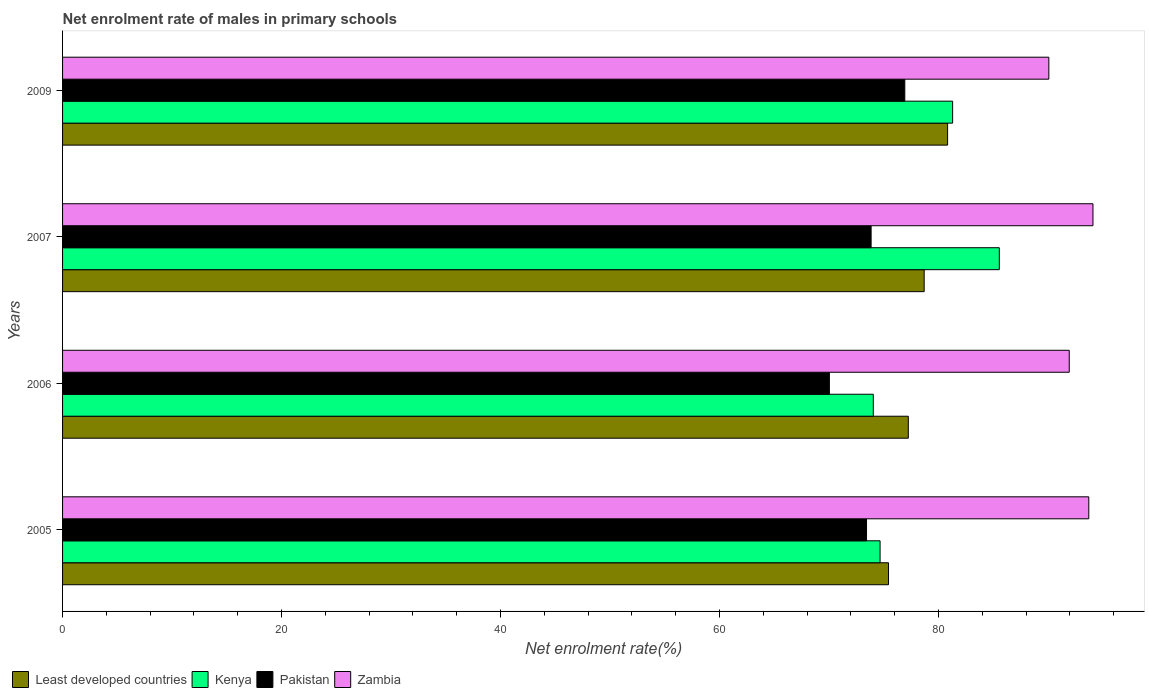How many different coloured bars are there?
Your answer should be very brief. 4. Are the number of bars on each tick of the Y-axis equal?
Your answer should be very brief. Yes. How many bars are there on the 4th tick from the top?
Keep it short and to the point. 4. What is the label of the 3rd group of bars from the top?
Your response must be concise. 2006. What is the net enrolment rate of males in primary schools in Zambia in 2006?
Provide a short and direct response. 91.95. Across all years, what is the maximum net enrolment rate of males in primary schools in Least developed countries?
Keep it short and to the point. 80.84. Across all years, what is the minimum net enrolment rate of males in primary schools in Least developed countries?
Provide a short and direct response. 75.44. In which year was the net enrolment rate of males in primary schools in Pakistan minimum?
Keep it short and to the point. 2006. What is the total net enrolment rate of males in primary schools in Pakistan in the graph?
Your answer should be very brief. 294.25. What is the difference between the net enrolment rate of males in primary schools in Pakistan in 2005 and that in 2007?
Provide a succinct answer. -0.42. What is the difference between the net enrolment rate of males in primary schools in Least developed countries in 2006 and the net enrolment rate of males in primary schools in Pakistan in 2005?
Offer a very short reply. 3.82. What is the average net enrolment rate of males in primary schools in Zambia per year?
Offer a terse response. 92.47. In the year 2009, what is the difference between the net enrolment rate of males in primary schools in Kenya and net enrolment rate of males in primary schools in Least developed countries?
Ensure brevity in your answer.  0.46. In how many years, is the net enrolment rate of males in primary schools in Pakistan greater than 16 %?
Your answer should be compact. 4. What is the ratio of the net enrolment rate of males in primary schools in Least developed countries in 2007 to that in 2009?
Offer a very short reply. 0.97. Is the net enrolment rate of males in primary schools in Pakistan in 2005 less than that in 2006?
Your answer should be compact. No. What is the difference between the highest and the second highest net enrolment rate of males in primary schools in Pakistan?
Offer a very short reply. 3.08. What is the difference between the highest and the lowest net enrolment rate of males in primary schools in Zambia?
Make the answer very short. 4.03. What does the 3rd bar from the top in 2007 represents?
Provide a succinct answer. Kenya. What does the 4th bar from the bottom in 2007 represents?
Offer a very short reply. Zambia. How many bars are there?
Ensure brevity in your answer.  16. How many years are there in the graph?
Offer a terse response. 4. What is the difference between two consecutive major ticks on the X-axis?
Offer a terse response. 20. Does the graph contain grids?
Offer a terse response. No. Where does the legend appear in the graph?
Ensure brevity in your answer.  Bottom left. How are the legend labels stacked?
Your answer should be very brief. Horizontal. What is the title of the graph?
Give a very brief answer. Net enrolment rate of males in primary schools. Does "Guatemala" appear as one of the legend labels in the graph?
Provide a succinct answer. No. What is the label or title of the X-axis?
Ensure brevity in your answer.  Net enrolment rate(%). What is the label or title of the Y-axis?
Give a very brief answer. Years. What is the Net enrolment rate(%) in Least developed countries in 2005?
Offer a very short reply. 75.44. What is the Net enrolment rate(%) of Kenya in 2005?
Your answer should be very brief. 74.67. What is the Net enrolment rate(%) of Pakistan in 2005?
Provide a short and direct response. 73.43. What is the Net enrolment rate(%) of Zambia in 2005?
Offer a terse response. 93.74. What is the Net enrolment rate(%) of Least developed countries in 2006?
Provide a short and direct response. 77.25. What is the Net enrolment rate(%) in Kenya in 2006?
Offer a terse response. 74.05. What is the Net enrolment rate(%) of Pakistan in 2006?
Your answer should be very brief. 70.04. What is the Net enrolment rate(%) of Zambia in 2006?
Keep it short and to the point. 91.95. What is the Net enrolment rate(%) of Least developed countries in 2007?
Give a very brief answer. 78.7. What is the Net enrolment rate(%) in Kenya in 2007?
Offer a very short reply. 85.56. What is the Net enrolment rate(%) of Pakistan in 2007?
Your answer should be very brief. 73.85. What is the Net enrolment rate(%) in Zambia in 2007?
Keep it short and to the point. 94.12. What is the Net enrolment rate(%) in Least developed countries in 2009?
Give a very brief answer. 80.84. What is the Net enrolment rate(%) of Kenya in 2009?
Provide a succinct answer. 81.3. What is the Net enrolment rate(%) of Pakistan in 2009?
Keep it short and to the point. 76.93. What is the Net enrolment rate(%) of Zambia in 2009?
Keep it short and to the point. 90.09. Across all years, what is the maximum Net enrolment rate(%) of Least developed countries?
Provide a succinct answer. 80.84. Across all years, what is the maximum Net enrolment rate(%) in Kenya?
Make the answer very short. 85.56. Across all years, what is the maximum Net enrolment rate(%) of Pakistan?
Provide a short and direct response. 76.93. Across all years, what is the maximum Net enrolment rate(%) of Zambia?
Offer a terse response. 94.12. Across all years, what is the minimum Net enrolment rate(%) in Least developed countries?
Ensure brevity in your answer.  75.44. Across all years, what is the minimum Net enrolment rate(%) in Kenya?
Ensure brevity in your answer.  74.05. Across all years, what is the minimum Net enrolment rate(%) in Pakistan?
Provide a short and direct response. 70.04. Across all years, what is the minimum Net enrolment rate(%) in Zambia?
Keep it short and to the point. 90.09. What is the total Net enrolment rate(%) of Least developed countries in the graph?
Provide a succinct answer. 312.23. What is the total Net enrolment rate(%) of Kenya in the graph?
Ensure brevity in your answer.  315.58. What is the total Net enrolment rate(%) of Pakistan in the graph?
Your answer should be very brief. 294.25. What is the total Net enrolment rate(%) of Zambia in the graph?
Keep it short and to the point. 369.88. What is the difference between the Net enrolment rate(%) in Least developed countries in 2005 and that in 2006?
Your answer should be very brief. -1.81. What is the difference between the Net enrolment rate(%) of Kenya in 2005 and that in 2006?
Your answer should be very brief. 0.62. What is the difference between the Net enrolment rate(%) in Pakistan in 2005 and that in 2006?
Provide a short and direct response. 3.39. What is the difference between the Net enrolment rate(%) of Zambia in 2005 and that in 2006?
Your response must be concise. 1.79. What is the difference between the Net enrolment rate(%) in Least developed countries in 2005 and that in 2007?
Your answer should be very brief. -3.26. What is the difference between the Net enrolment rate(%) of Kenya in 2005 and that in 2007?
Provide a short and direct response. -10.89. What is the difference between the Net enrolment rate(%) of Pakistan in 2005 and that in 2007?
Your answer should be compact. -0.42. What is the difference between the Net enrolment rate(%) in Zambia in 2005 and that in 2007?
Your answer should be very brief. -0.38. What is the difference between the Net enrolment rate(%) in Least developed countries in 2005 and that in 2009?
Provide a succinct answer. -5.4. What is the difference between the Net enrolment rate(%) of Kenya in 2005 and that in 2009?
Make the answer very short. -6.63. What is the difference between the Net enrolment rate(%) in Pakistan in 2005 and that in 2009?
Your answer should be compact. -3.49. What is the difference between the Net enrolment rate(%) of Zambia in 2005 and that in 2009?
Your response must be concise. 3.65. What is the difference between the Net enrolment rate(%) of Least developed countries in 2006 and that in 2007?
Offer a terse response. -1.45. What is the difference between the Net enrolment rate(%) in Kenya in 2006 and that in 2007?
Your answer should be compact. -11.51. What is the difference between the Net enrolment rate(%) in Pakistan in 2006 and that in 2007?
Keep it short and to the point. -3.81. What is the difference between the Net enrolment rate(%) in Zambia in 2006 and that in 2007?
Your response must be concise. -2.17. What is the difference between the Net enrolment rate(%) in Least developed countries in 2006 and that in 2009?
Provide a short and direct response. -3.59. What is the difference between the Net enrolment rate(%) of Kenya in 2006 and that in 2009?
Provide a succinct answer. -7.25. What is the difference between the Net enrolment rate(%) of Pakistan in 2006 and that in 2009?
Offer a very short reply. -6.89. What is the difference between the Net enrolment rate(%) in Zambia in 2006 and that in 2009?
Offer a terse response. 1.86. What is the difference between the Net enrolment rate(%) of Least developed countries in 2007 and that in 2009?
Offer a terse response. -2.14. What is the difference between the Net enrolment rate(%) of Kenya in 2007 and that in 2009?
Offer a terse response. 4.26. What is the difference between the Net enrolment rate(%) of Pakistan in 2007 and that in 2009?
Your response must be concise. -3.08. What is the difference between the Net enrolment rate(%) in Zambia in 2007 and that in 2009?
Offer a terse response. 4.03. What is the difference between the Net enrolment rate(%) in Least developed countries in 2005 and the Net enrolment rate(%) in Kenya in 2006?
Offer a terse response. 1.39. What is the difference between the Net enrolment rate(%) of Least developed countries in 2005 and the Net enrolment rate(%) of Pakistan in 2006?
Keep it short and to the point. 5.4. What is the difference between the Net enrolment rate(%) in Least developed countries in 2005 and the Net enrolment rate(%) in Zambia in 2006?
Offer a terse response. -16.51. What is the difference between the Net enrolment rate(%) in Kenya in 2005 and the Net enrolment rate(%) in Pakistan in 2006?
Provide a short and direct response. 4.63. What is the difference between the Net enrolment rate(%) of Kenya in 2005 and the Net enrolment rate(%) of Zambia in 2006?
Your response must be concise. -17.28. What is the difference between the Net enrolment rate(%) of Pakistan in 2005 and the Net enrolment rate(%) of Zambia in 2006?
Your answer should be compact. -18.52. What is the difference between the Net enrolment rate(%) in Least developed countries in 2005 and the Net enrolment rate(%) in Kenya in 2007?
Your answer should be compact. -10.12. What is the difference between the Net enrolment rate(%) of Least developed countries in 2005 and the Net enrolment rate(%) of Pakistan in 2007?
Offer a very short reply. 1.59. What is the difference between the Net enrolment rate(%) of Least developed countries in 2005 and the Net enrolment rate(%) of Zambia in 2007?
Provide a succinct answer. -18.67. What is the difference between the Net enrolment rate(%) of Kenya in 2005 and the Net enrolment rate(%) of Pakistan in 2007?
Keep it short and to the point. 0.82. What is the difference between the Net enrolment rate(%) in Kenya in 2005 and the Net enrolment rate(%) in Zambia in 2007?
Keep it short and to the point. -19.45. What is the difference between the Net enrolment rate(%) in Pakistan in 2005 and the Net enrolment rate(%) in Zambia in 2007?
Offer a terse response. -20.68. What is the difference between the Net enrolment rate(%) of Least developed countries in 2005 and the Net enrolment rate(%) of Kenya in 2009?
Your response must be concise. -5.86. What is the difference between the Net enrolment rate(%) in Least developed countries in 2005 and the Net enrolment rate(%) in Pakistan in 2009?
Provide a short and direct response. -1.49. What is the difference between the Net enrolment rate(%) in Least developed countries in 2005 and the Net enrolment rate(%) in Zambia in 2009?
Make the answer very short. -14.64. What is the difference between the Net enrolment rate(%) in Kenya in 2005 and the Net enrolment rate(%) in Pakistan in 2009?
Your response must be concise. -2.26. What is the difference between the Net enrolment rate(%) in Kenya in 2005 and the Net enrolment rate(%) in Zambia in 2009?
Keep it short and to the point. -15.41. What is the difference between the Net enrolment rate(%) of Pakistan in 2005 and the Net enrolment rate(%) of Zambia in 2009?
Your answer should be very brief. -16.65. What is the difference between the Net enrolment rate(%) in Least developed countries in 2006 and the Net enrolment rate(%) in Kenya in 2007?
Keep it short and to the point. -8.31. What is the difference between the Net enrolment rate(%) of Least developed countries in 2006 and the Net enrolment rate(%) of Pakistan in 2007?
Your answer should be compact. 3.4. What is the difference between the Net enrolment rate(%) of Least developed countries in 2006 and the Net enrolment rate(%) of Zambia in 2007?
Your answer should be compact. -16.87. What is the difference between the Net enrolment rate(%) of Kenya in 2006 and the Net enrolment rate(%) of Pakistan in 2007?
Provide a succinct answer. 0.2. What is the difference between the Net enrolment rate(%) of Kenya in 2006 and the Net enrolment rate(%) of Zambia in 2007?
Make the answer very short. -20.07. What is the difference between the Net enrolment rate(%) in Pakistan in 2006 and the Net enrolment rate(%) in Zambia in 2007?
Offer a very short reply. -24.07. What is the difference between the Net enrolment rate(%) of Least developed countries in 2006 and the Net enrolment rate(%) of Kenya in 2009?
Your answer should be compact. -4.05. What is the difference between the Net enrolment rate(%) of Least developed countries in 2006 and the Net enrolment rate(%) of Pakistan in 2009?
Your answer should be compact. 0.32. What is the difference between the Net enrolment rate(%) of Least developed countries in 2006 and the Net enrolment rate(%) of Zambia in 2009?
Give a very brief answer. -12.84. What is the difference between the Net enrolment rate(%) of Kenya in 2006 and the Net enrolment rate(%) of Pakistan in 2009?
Make the answer very short. -2.88. What is the difference between the Net enrolment rate(%) in Kenya in 2006 and the Net enrolment rate(%) in Zambia in 2009?
Your response must be concise. -16.03. What is the difference between the Net enrolment rate(%) in Pakistan in 2006 and the Net enrolment rate(%) in Zambia in 2009?
Ensure brevity in your answer.  -20.04. What is the difference between the Net enrolment rate(%) in Least developed countries in 2007 and the Net enrolment rate(%) in Kenya in 2009?
Your response must be concise. -2.6. What is the difference between the Net enrolment rate(%) in Least developed countries in 2007 and the Net enrolment rate(%) in Pakistan in 2009?
Ensure brevity in your answer.  1.77. What is the difference between the Net enrolment rate(%) in Least developed countries in 2007 and the Net enrolment rate(%) in Zambia in 2009?
Make the answer very short. -11.39. What is the difference between the Net enrolment rate(%) of Kenya in 2007 and the Net enrolment rate(%) of Pakistan in 2009?
Provide a short and direct response. 8.63. What is the difference between the Net enrolment rate(%) of Kenya in 2007 and the Net enrolment rate(%) of Zambia in 2009?
Ensure brevity in your answer.  -4.52. What is the difference between the Net enrolment rate(%) in Pakistan in 2007 and the Net enrolment rate(%) in Zambia in 2009?
Offer a very short reply. -16.23. What is the average Net enrolment rate(%) of Least developed countries per year?
Provide a succinct answer. 78.06. What is the average Net enrolment rate(%) of Kenya per year?
Provide a succinct answer. 78.89. What is the average Net enrolment rate(%) in Pakistan per year?
Keep it short and to the point. 73.56. What is the average Net enrolment rate(%) of Zambia per year?
Ensure brevity in your answer.  92.47. In the year 2005, what is the difference between the Net enrolment rate(%) in Least developed countries and Net enrolment rate(%) in Kenya?
Keep it short and to the point. 0.77. In the year 2005, what is the difference between the Net enrolment rate(%) of Least developed countries and Net enrolment rate(%) of Pakistan?
Keep it short and to the point. 2.01. In the year 2005, what is the difference between the Net enrolment rate(%) in Least developed countries and Net enrolment rate(%) in Zambia?
Your response must be concise. -18.29. In the year 2005, what is the difference between the Net enrolment rate(%) in Kenya and Net enrolment rate(%) in Pakistan?
Your answer should be very brief. 1.24. In the year 2005, what is the difference between the Net enrolment rate(%) of Kenya and Net enrolment rate(%) of Zambia?
Make the answer very short. -19.06. In the year 2005, what is the difference between the Net enrolment rate(%) in Pakistan and Net enrolment rate(%) in Zambia?
Provide a succinct answer. -20.3. In the year 2006, what is the difference between the Net enrolment rate(%) of Least developed countries and Net enrolment rate(%) of Kenya?
Provide a short and direct response. 3.2. In the year 2006, what is the difference between the Net enrolment rate(%) in Least developed countries and Net enrolment rate(%) in Pakistan?
Your response must be concise. 7.21. In the year 2006, what is the difference between the Net enrolment rate(%) in Least developed countries and Net enrolment rate(%) in Zambia?
Give a very brief answer. -14.7. In the year 2006, what is the difference between the Net enrolment rate(%) in Kenya and Net enrolment rate(%) in Pakistan?
Provide a succinct answer. 4.01. In the year 2006, what is the difference between the Net enrolment rate(%) in Kenya and Net enrolment rate(%) in Zambia?
Make the answer very short. -17.9. In the year 2006, what is the difference between the Net enrolment rate(%) of Pakistan and Net enrolment rate(%) of Zambia?
Your answer should be compact. -21.91. In the year 2007, what is the difference between the Net enrolment rate(%) of Least developed countries and Net enrolment rate(%) of Kenya?
Your response must be concise. -6.86. In the year 2007, what is the difference between the Net enrolment rate(%) in Least developed countries and Net enrolment rate(%) in Pakistan?
Your answer should be compact. 4.85. In the year 2007, what is the difference between the Net enrolment rate(%) in Least developed countries and Net enrolment rate(%) in Zambia?
Your answer should be compact. -15.42. In the year 2007, what is the difference between the Net enrolment rate(%) of Kenya and Net enrolment rate(%) of Pakistan?
Give a very brief answer. 11.71. In the year 2007, what is the difference between the Net enrolment rate(%) in Kenya and Net enrolment rate(%) in Zambia?
Your answer should be compact. -8.56. In the year 2007, what is the difference between the Net enrolment rate(%) in Pakistan and Net enrolment rate(%) in Zambia?
Ensure brevity in your answer.  -20.26. In the year 2009, what is the difference between the Net enrolment rate(%) in Least developed countries and Net enrolment rate(%) in Kenya?
Make the answer very short. -0.46. In the year 2009, what is the difference between the Net enrolment rate(%) of Least developed countries and Net enrolment rate(%) of Pakistan?
Your answer should be compact. 3.91. In the year 2009, what is the difference between the Net enrolment rate(%) in Least developed countries and Net enrolment rate(%) in Zambia?
Your answer should be compact. -9.25. In the year 2009, what is the difference between the Net enrolment rate(%) of Kenya and Net enrolment rate(%) of Pakistan?
Your answer should be very brief. 4.37. In the year 2009, what is the difference between the Net enrolment rate(%) in Kenya and Net enrolment rate(%) in Zambia?
Make the answer very short. -8.79. In the year 2009, what is the difference between the Net enrolment rate(%) in Pakistan and Net enrolment rate(%) in Zambia?
Provide a short and direct response. -13.16. What is the ratio of the Net enrolment rate(%) in Least developed countries in 2005 to that in 2006?
Your response must be concise. 0.98. What is the ratio of the Net enrolment rate(%) in Kenya in 2005 to that in 2006?
Make the answer very short. 1.01. What is the ratio of the Net enrolment rate(%) of Pakistan in 2005 to that in 2006?
Ensure brevity in your answer.  1.05. What is the ratio of the Net enrolment rate(%) in Zambia in 2005 to that in 2006?
Provide a short and direct response. 1.02. What is the ratio of the Net enrolment rate(%) in Least developed countries in 2005 to that in 2007?
Ensure brevity in your answer.  0.96. What is the ratio of the Net enrolment rate(%) in Kenya in 2005 to that in 2007?
Provide a succinct answer. 0.87. What is the ratio of the Net enrolment rate(%) in Pakistan in 2005 to that in 2007?
Your answer should be very brief. 0.99. What is the ratio of the Net enrolment rate(%) in Zambia in 2005 to that in 2007?
Provide a succinct answer. 1. What is the ratio of the Net enrolment rate(%) of Least developed countries in 2005 to that in 2009?
Make the answer very short. 0.93. What is the ratio of the Net enrolment rate(%) in Kenya in 2005 to that in 2009?
Your answer should be compact. 0.92. What is the ratio of the Net enrolment rate(%) of Pakistan in 2005 to that in 2009?
Provide a short and direct response. 0.95. What is the ratio of the Net enrolment rate(%) in Zambia in 2005 to that in 2009?
Your response must be concise. 1.04. What is the ratio of the Net enrolment rate(%) of Least developed countries in 2006 to that in 2007?
Your answer should be very brief. 0.98. What is the ratio of the Net enrolment rate(%) of Kenya in 2006 to that in 2007?
Provide a short and direct response. 0.87. What is the ratio of the Net enrolment rate(%) of Pakistan in 2006 to that in 2007?
Give a very brief answer. 0.95. What is the ratio of the Net enrolment rate(%) of Zambia in 2006 to that in 2007?
Keep it short and to the point. 0.98. What is the ratio of the Net enrolment rate(%) in Least developed countries in 2006 to that in 2009?
Ensure brevity in your answer.  0.96. What is the ratio of the Net enrolment rate(%) in Kenya in 2006 to that in 2009?
Provide a short and direct response. 0.91. What is the ratio of the Net enrolment rate(%) in Pakistan in 2006 to that in 2009?
Offer a terse response. 0.91. What is the ratio of the Net enrolment rate(%) in Zambia in 2006 to that in 2009?
Provide a short and direct response. 1.02. What is the ratio of the Net enrolment rate(%) of Least developed countries in 2007 to that in 2009?
Provide a short and direct response. 0.97. What is the ratio of the Net enrolment rate(%) of Kenya in 2007 to that in 2009?
Make the answer very short. 1.05. What is the ratio of the Net enrolment rate(%) in Pakistan in 2007 to that in 2009?
Provide a succinct answer. 0.96. What is the ratio of the Net enrolment rate(%) of Zambia in 2007 to that in 2009?
Ensure brevity in your answer.  1.04. What is the difference between the highest and the second highest Net enrolment rate(%) in Least developed countries?
Offer a very short reply. 2.14. What is the difference between the highest and the second highest Net enrolment rate(%) in Kenya?
Your answer should be very brief. 4.26. What is the difference between the highest and the second highest Net enrolment rate(%) in Pakistan?
Your answer should be compact. 3.08. What is the difference between the highest and the second highest Net enrolment rate(%) of Zambia?
Offer a terse response. 0.38. What is the difference between the highest and the lowest Net enrolment rate(%) of Least developed countries?
Offer a terse response. 5.4. What is the difference between the highest and the lowest Net enrolment rate(%) of Kenya?
Your answer should be compact. 11.51. What is the difference between the highest and the lowest Net enrolment rate(%) of Pakistan?
Provide a succinct answer. 6.89. What is the difference between the highest and the lowest Net enrolment rate(%) of Zambia?
Ensure brevity in your answer.  4.03. 